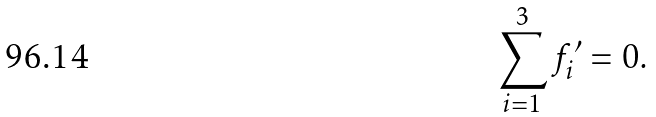Convert formula to latex. <formula><loc_0><loc_0><loc_500><loc_500>\sum _ { i = 1 } ^ { 3 } f _ { i } ^ { \prime } = 0 .</formula> 